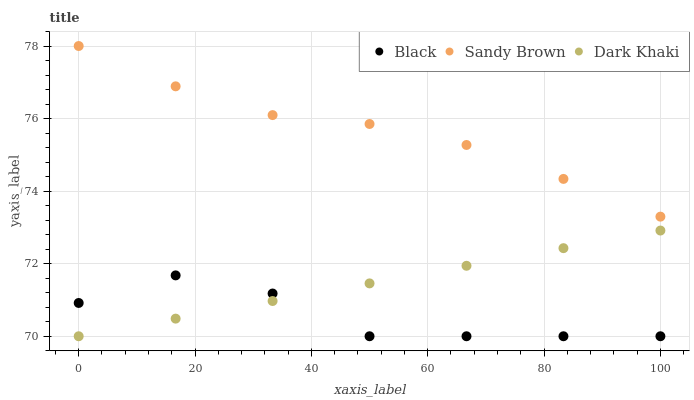Does Black have the minimum area under the curve?
Answer yes or no. Yes. Does Sandy Brown have the maximum area under the curve?
Answer yes or no. Yes. Does Sandy Brown have the minimum area under the curve?
Answer yes or no. No. Does Black have the maximum area under the curve?
Answer yes or no. No. Is Dark Khaki the smoothest?
Answer yes or no. Yes. Is Black the roughest?
Answer yes or no. Yes. Is Sandy Brown the smoothest?
Answer yes or no. No. Is Sandy Brown the roughest?
Answer yes or no. No. Does Dark Khaki have the lowest value?
Answer yes or no. Yes. Does Sandy Brown have the lowest value?
Answer yes or no. No. Does Sandy Brown have the highest value?
Answer yes or no. Yes. Does Black have the highest value?
Answer yes or no. No. Is Black less than Sandy Brown?
Answer yes or no. Yes. Is Sandy Brown greater than Dark Khaki?
Answer yes or no. Yes. Does Black intersect Dark Khaki?
Answer yes or no. Yes. Is Black less than Dark Khaki?
Answer yes or no. No. Is Black greater than Dark Khaki?
Answer yes or no. No. Does Black intersect Sandy Brown?
Answer yes or no. No. 